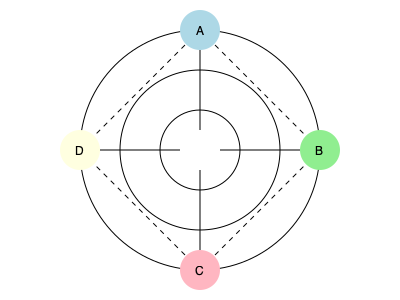In this network graph representing character relationships in a complex sci-fi narrative, what does the structure suggest about the central character's role, and how might this visualization aid in storytelling? 1. Graph structure:
   - The graph shows four characters (A, B, C, D) arranged in a circular pattern.
   - Character A is at the top, B on the right, C at the bottom, and D on the left.
   - There are three concentric circles, suggesting layers of relationships or influence.

2. Connection types:
   - Solid lines connect each character to the center, indicating direct relationships.
   - Dashed lines connect characters on the outer circle, suggesting indirect or secondary relationships.

3. Central character's role:
   - The center of the graph, where all solid lines converge, represents a central character or concept.
   - This central element connects directly to all other characters, implying it plays a pivotal role in the narrative.

4. Character relationships:
   - Characters A, B, C, and D are equidistant from the center and each other, suggesting balanced importance.
   - The dashed lines between outer characters imply interactions or relationships independent of the central element.

5. Layers of influence:
   - The three concentric circles could represent different levels of plot complexity, character development, or story arcs.
   - Characters positioned on the outer circle may have the most complex or far-reaching storylines.

6. Storytelling aid:
   - This visualization helps identify key relationships and plot connections at a glance.
   - It can assist in maintaining consistency in complex narratives with multiple interacting characters.
   - The graph structure can guide the pacing and development of character arcs throughout the story.

7. Data science perspective:
   - This network graph is a powerful tool for analyzing and planning narrative structures.
   - It allows for quantitative analysis of character interactions and plot complexities.
   - The visualization can be expanded or modified as the story develops, providing a dynamic tool for narrative management.
Answer: Central hub in layered network, facilitating complex character interactions and plot development 